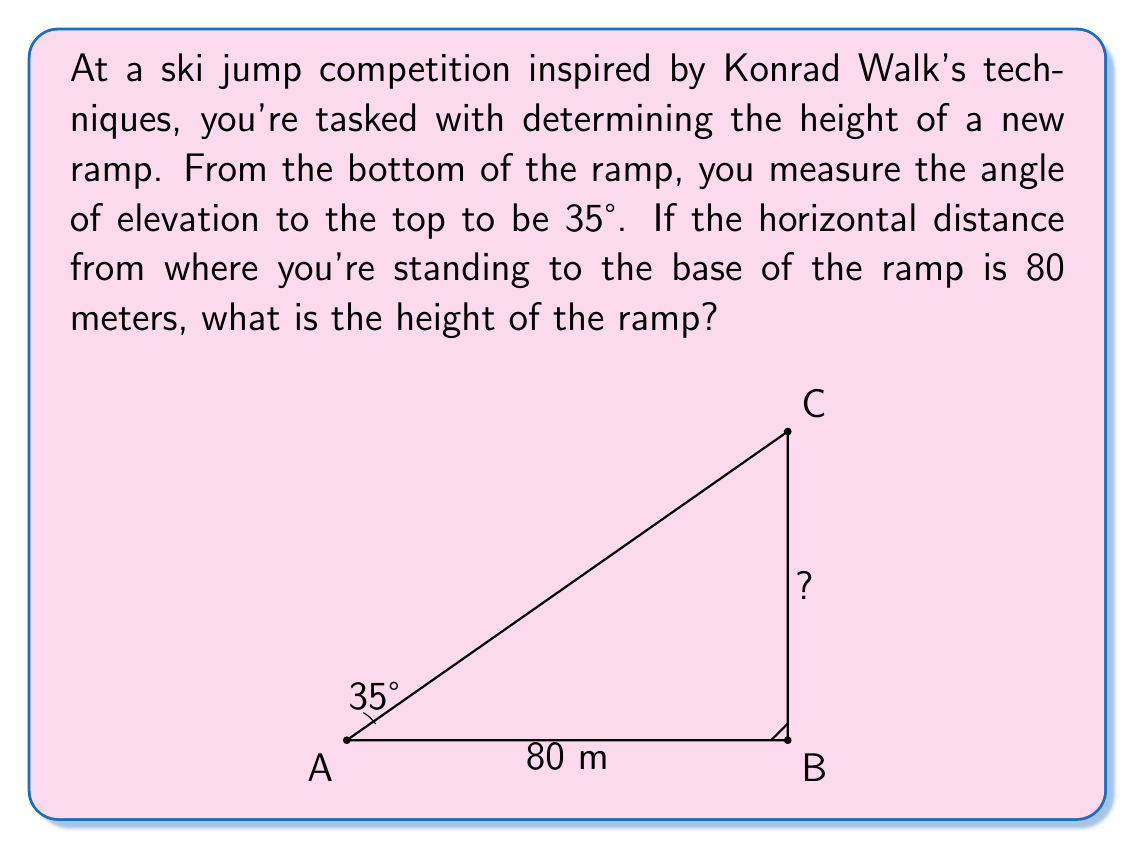What is the answer to this math problem? Let's approach this step-by-step using trigonometric ratios:

1) In this problem, we have a right-angled triangle. The angle of elevation (35°) forms the angle between the horizontal base and the hypotenuse.

2) We need to find the opposite side (height of the ramp) given the adjacent side (80 meters) and the angle (35°).

3) The trigonometric ratio that relates the opposite and adjacent sides is the tangent:

   $\tan \theta = \frac{\text{opposite}}{\text{adjacent}}$

4) Let's call the height of the ramp $h$. We can set up the equation:

   $\tan 35° = \frac{h}{80}$

5) To solve for $h$, we multiply both sides by 80:

   $h = 80 \tan 35°$

6) Using a calculator or trigonometric tables:

   $h = 80 \times 0.7002075$

7) This gives us:

   $h \approx 56.0166$ meters

8) Rounding to a reasonable precision for a ski ramp height:

   $h \approx 56.02$ meters
Answer: The height of the ski jump ramp is approximately 56.02 meters. 